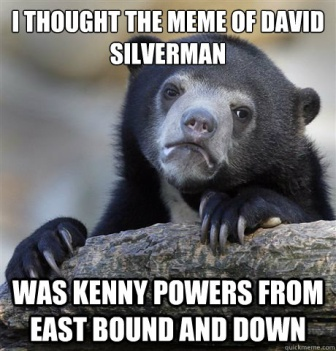Create a creative and imaginative story involving the bear and its mix-up. In a mystical forest where animals secretly run a sophisticated intelligence network, Barry the black bear is the top agent. One day, while decoding secret messages left by the squirrels, Barry stumbles upon a bizarre piece of intel. The message reads, ‘David Silverman is Kenny Powers from East Bound and Down.’ Confused, Barry dons his monocle and sets off on an adventure to a secret library hidden beneath the roots of an ancient oak tree.

Upon arrival, Barry consults the wise owl librarian who chuckles and explains the mix-up. Enlightened, Barry realizes the message was a prank by the mischievous raccoons. With a chuckle, he heads back to his tree trunk office, pondering the owl’s suggestion about starting a forest book club to educate everyone about pop culture, ensuring such mix-ups never happen again. Barry’s puzzled look quickly turns to a determined smile as he plans his next mission: transforming himself into the forest’s pop culture guru. 